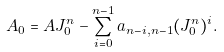<formula> <loc_0><loc_0><loc_500><loc_500>A _ { 0 } = A J _ { 0 } ^ { n } - \sum _ { i = 0 } ^ { n - 1 } a _ { n - i , n - 1 } ( J _ { 0 } ^ { n } ) ^ { i } .</formula> 